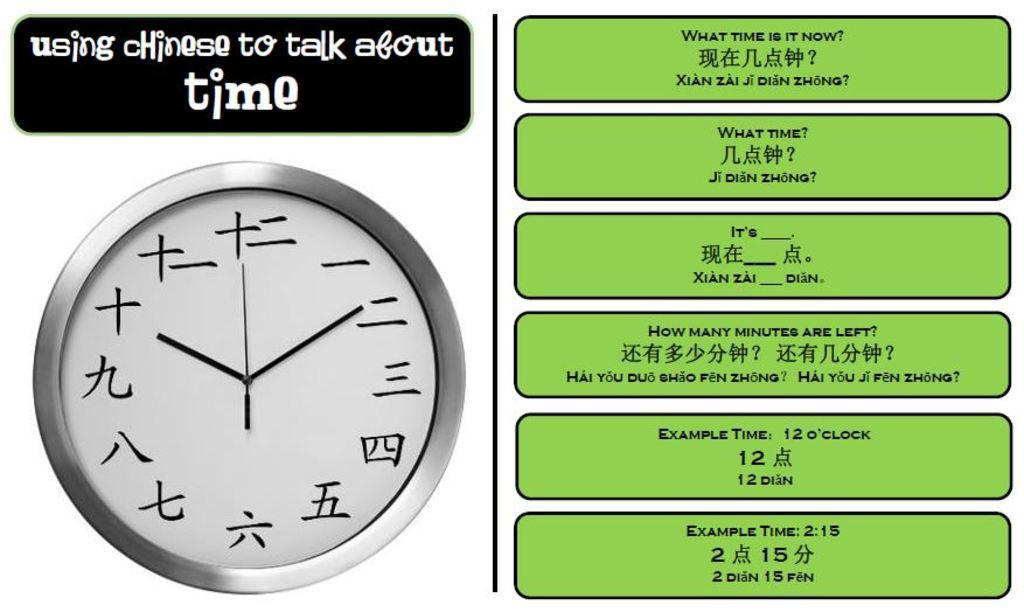Provide a one-sentence caption for the provided image. A clock has a sign above it and green boxes to the side showing example times. 